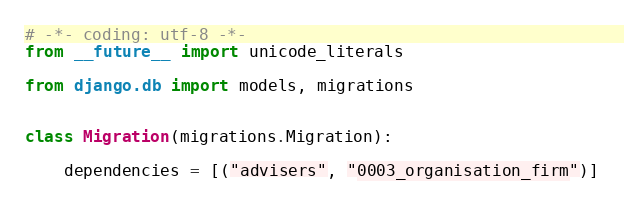Convert code to text. <code><loc_0><loc_0><loc_500><loc_500><_Python_># -*- coding: utf-8 -*-
from __future__ import unicode_literals

from django.db import models, migrations


class Migration(migrations.Migration):

    dependencies = [("advisers", "0003_organisation_firm")]
</code> 